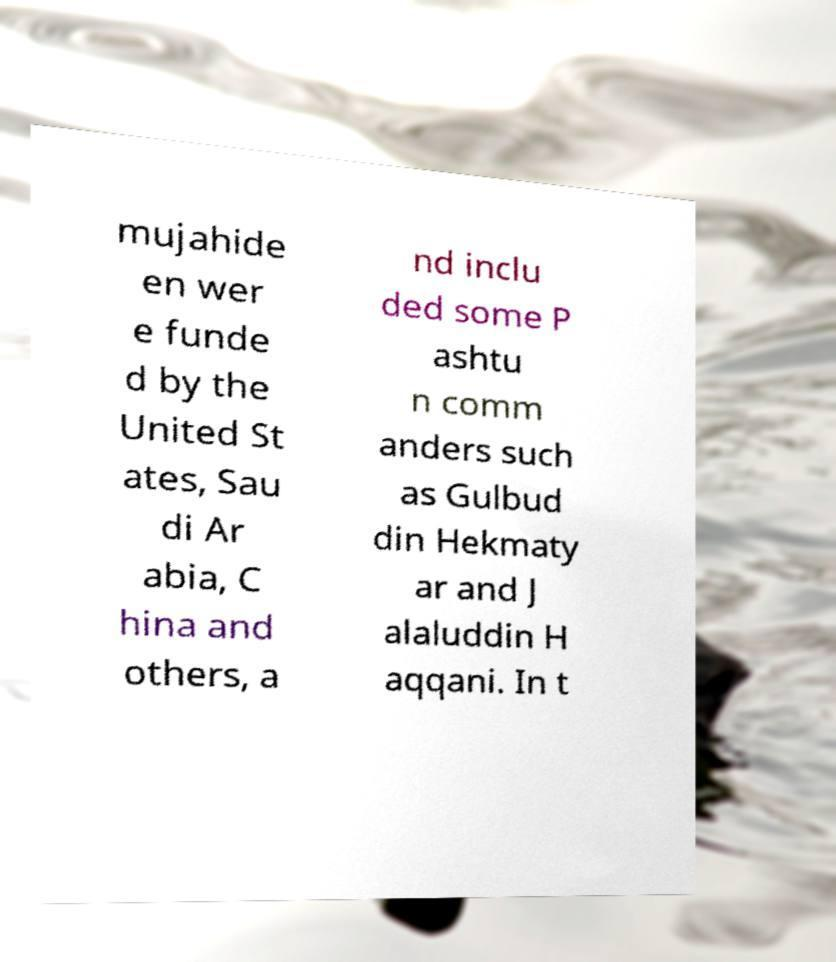Can you read and provide the text displayed in the image?This photo seems to have some interesting text. Can you extract and type it out for me? mujahide en wer e funde d by the United St ates, Sau di Ar abia, C hina and others, a nd inclu ded some P ashtu n comm anders such as Gulbud din Hekmaty ar and J alaluddin H aqqani. In t 